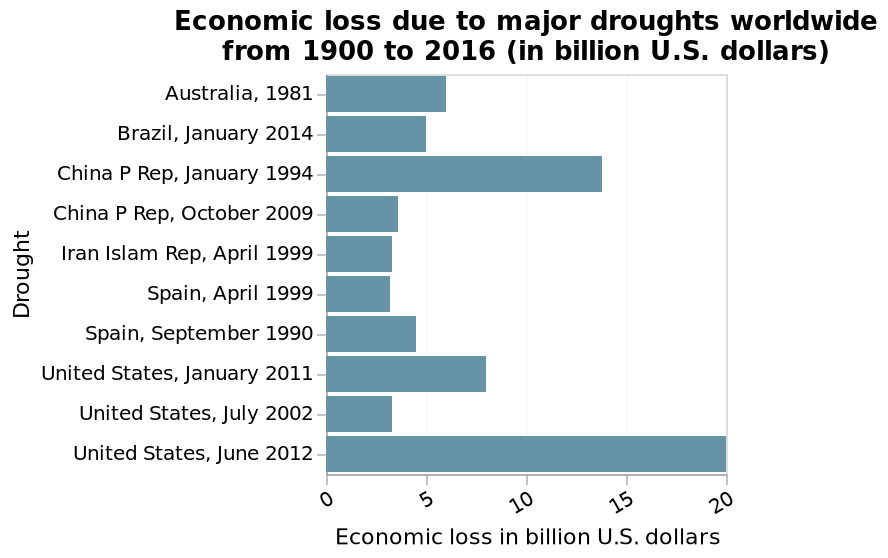<image>
Which country has suffered the greatest economic loss due to drought?  The United States has suffered the greatest economic loss due to drought. Offer a thorough analysis of the image. The United States has suffered the world's greatest economic loss due to drought over the 116 years of the data set. The US has lost approx 30bn US dollars in total. This is followed by China at about 18bn dollars, and Spain at around 7bn USD. The US has suffered three major droughts in all, with the worst economic losses in 2012. 